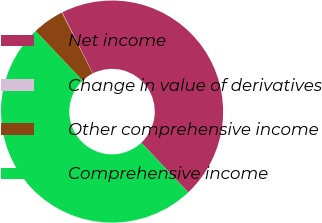Convert chart to OTSL. <chart><loc_0><loc_0><loc_500><loc_500><pie_chart><fcel>Net income<fcel>Change in value of derivatives<fcel>Other comprehensive income<fcel>Comprehensive income<nl><fcel>45.39%<fcel>0.07%<fcel>4.61%<fcel>49.93%<nl></chart> 